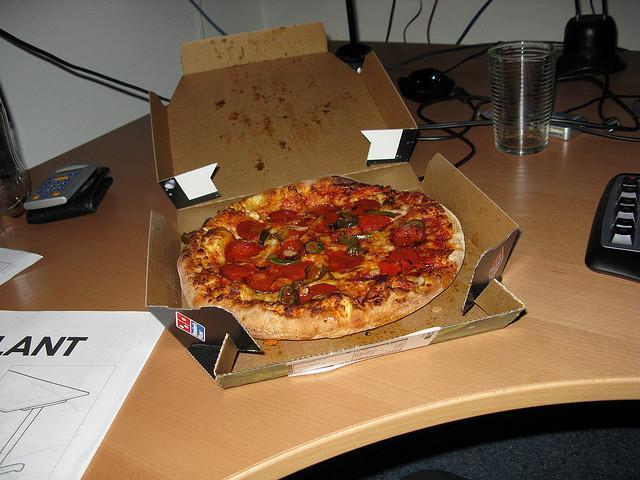How many cut slices does the pizza have cut?
Give a very brief answer. 0. 